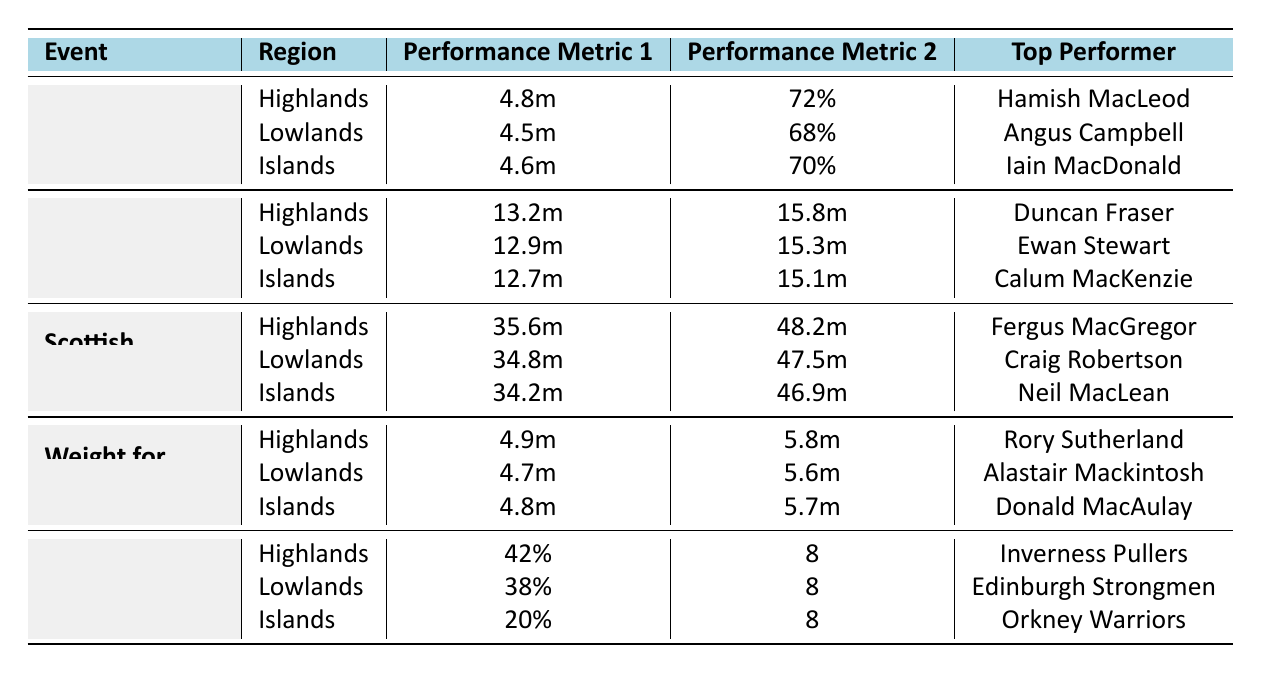What is the average distance of the Caber Toss in the Highlands? The table shows that the average distance for the Caber Toss in the Highlands is listed as 4.8 meters.
Answer: 4.8m Who is the top performer for the Stone Put in the Islands? The table specifies that the top performer for the Stone Put in the Islands is Calum MacKenzie.
Answer: Calum MacKenzie What percentage of successful attempts does the Lowlands region have for the Caber Toss? According to the table, the successful attempts percentage for the Lowlands in the Caber Toss event is 68%.
Answer: 68% Which event has the highest average distance in the Highlands? In the Highlands, the Scottish Hammer Throw has the highest average distance at 35.6 meters compared to Caber Toss (4.8m) and Stone Put (13.2m).
Answer: Scottish Hammer Throw Is the average height for the Weight for Height event in the Islands greater than or equal to 4.8 meters? The average height for the Weight for Height event in the Islands is 4.8 meters, which means it is equal to 4.8 meters. Therefore, the statement is true.
Answer: Yes What is the difference in average distance between the Stone Put in the Highlands and the Lowlands? The average distance for the Stone Put in the Highlands is 13.2 meters, while in the Lowlands it is 12.9 meters. The difference is 13.2m - 12.9m = 0.3m.
Answer: 0.3m Which region has the lowest successful attempts percentage in the Caber Toss event? The table shows that the Lowlands region has the lowest successful attempts percentage (68%) compared to the Highlands (72%) and Islands (70%).
Answer: Lowlands What is the maximum height achieved in the Weight for Height event in the Highlands? The table lists the maximum height for the Weight for Height in the Highlands as 5.8 meters.
Answer: 5.8m If we were to average the successful attempts percentages from all regions in the Caber Toss, what would that be? The successful attempts percentages for the Caber Toss are: Highlands 72%, Lowlands 68%, Islands 70%. To average: (72 + 68 + 70) / 3 = 70%.
Answer: 70% Which team has the highest win percentage in the Tug o' War event? The Tug o' War event shows that the Highlands team, Inverness Pullers, has the highest win percentage at 42%.
Answer: Inverness Pullers 